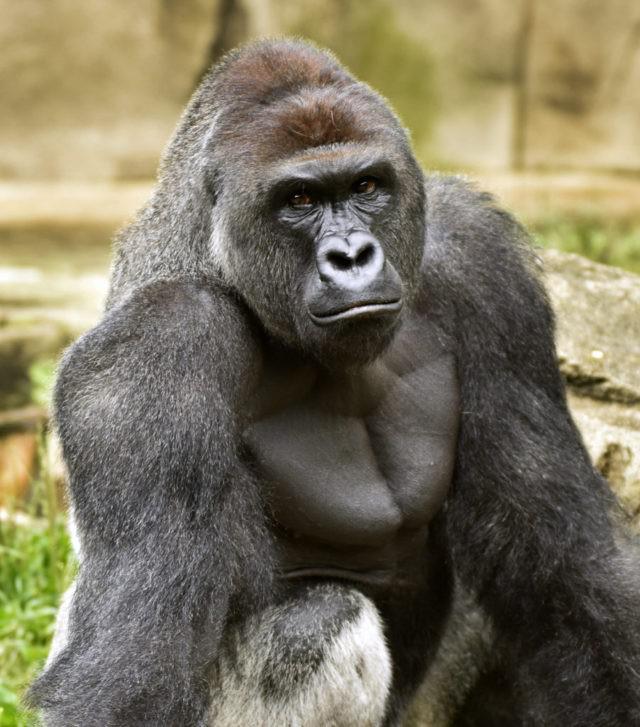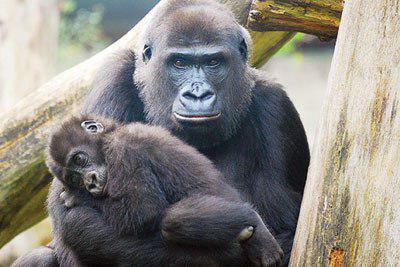The first image is the image on the left, the second image is the image on the right. Considering the images on both sides, is "The animal in the image on the left is holding food." valid? Answer yes or no. No. 